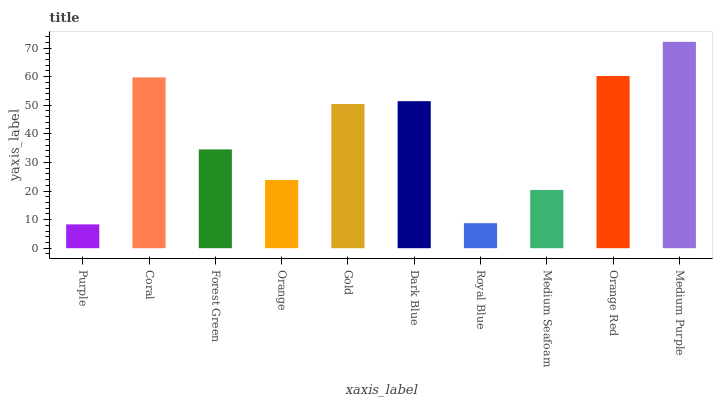Is Purple the minimum?
Answer yes or no. Yes. Is Medium Purple the maximum?
Answer yes or no. Yes. Is Coral the minimum?
Answer yes or no. No. Is Coral the maximum?
Answer yes or no. No. Is Coral greater than Purple?
Answer yes or no. Yes. Is Purple less than Coral?
Answer yes or no. Yes. Is Purple greater than Coral?
Answer yes or no. No. Is Coral less than Purple?
Answer yes or no. No. Is Gold the high median?
Answer yes or no. Yes. Is Forest Green the low median?
Answer yes or no. Yes. Is Forest Green the high median?
Answer yes or no. No. Is Orange the low median?
Answer yes or no. No. 